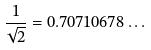<formula> <loc_0><loc_0><loc_500><loc_500>\frac { 1 } { \sqrt { 2 } } = 0 . 7 0 7 1 0 6 7 8 \dots</formula> 